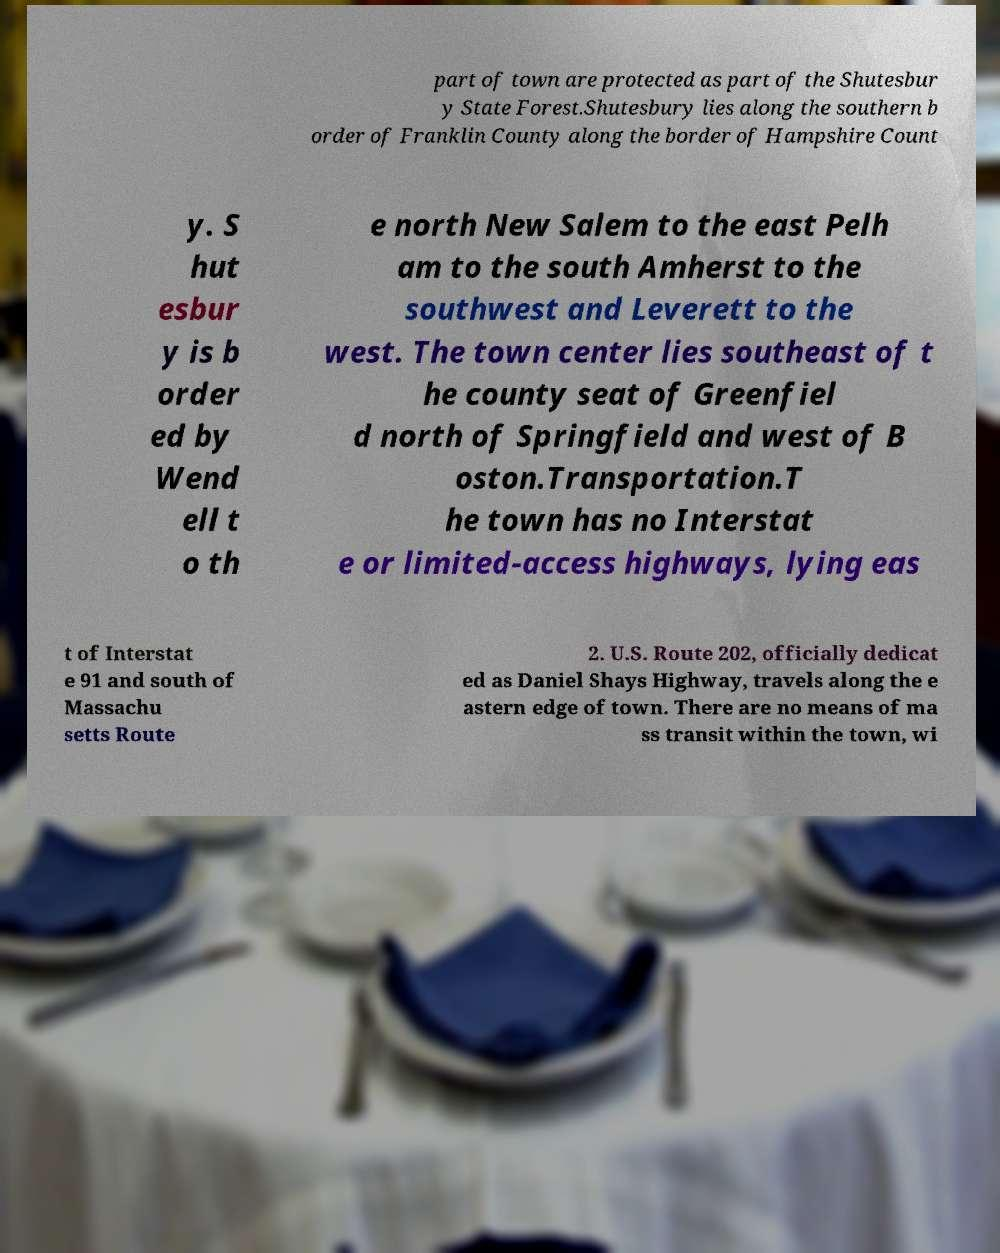There's text embedded in this image that I need extracted. Can you transcribe it verbatim? part of town are protected as part of the Shutesbur y State Forest.Shutesbury lies along the southern b order of Franklin County along the border of Hampshire Count y. S hut esbur y is b order ed by Wend ell t o th e north New Salem to the east Pelh am to the south Amherst to the southwest and Leverett to the west. The town center lies southeast of t he county seat of Greenfiel d north of Springfield and west of B oston.Transportation.T he town has no Interstat e or limited-access highways, lying eas t of Interstat e 91 and south of Massachu setts Route 2. U.S. Route 202, officially dedicat ed as Daniel Shays Highway, travels along the e astern edge of town. There are no means of ma ss transit within the town, wi 